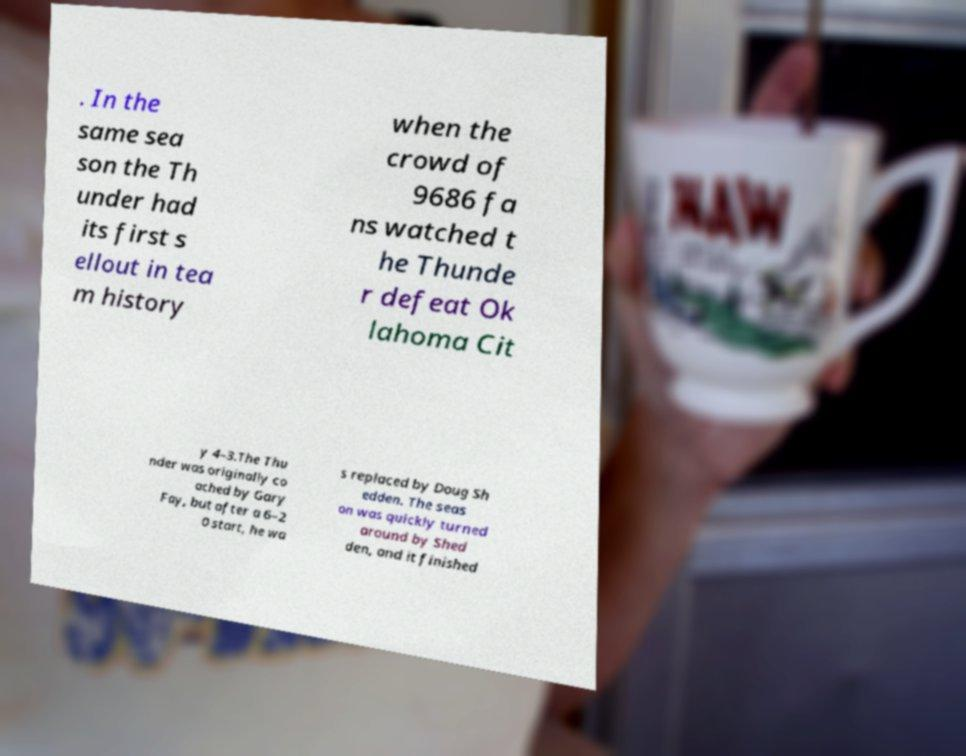Please identify and transcribe the text found in this image. . In the same sea son the Th under had its first s ellout in tea m history when the crowd of 9686 fa ns watched t he Thunde r defeat Ok lahoma Cit y 4–3.The Thu nder was originally co ached by Gary Fay, but after a 6–2 0 start, he wa s replaced by Doug Sh edden. The seas on was quickly turned around by Shed den, and it finished 